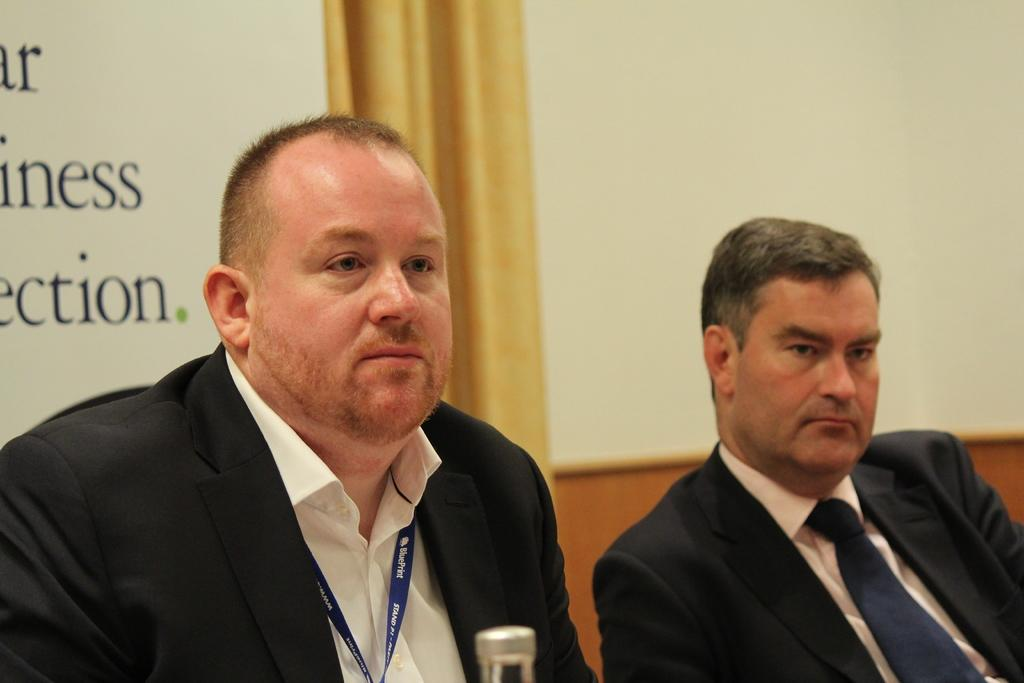How many people are sitting in the image? There are two people sitting in the image. What are the people wearing? The people are wearing suits. What can be seen in the background of the image? There are boards and a curtain in the background of the image. Can you see any cats or horses in the image? No, there are no cats or horses present in the image. Is there a van visible in the image? No, there is no van visible in the image. 